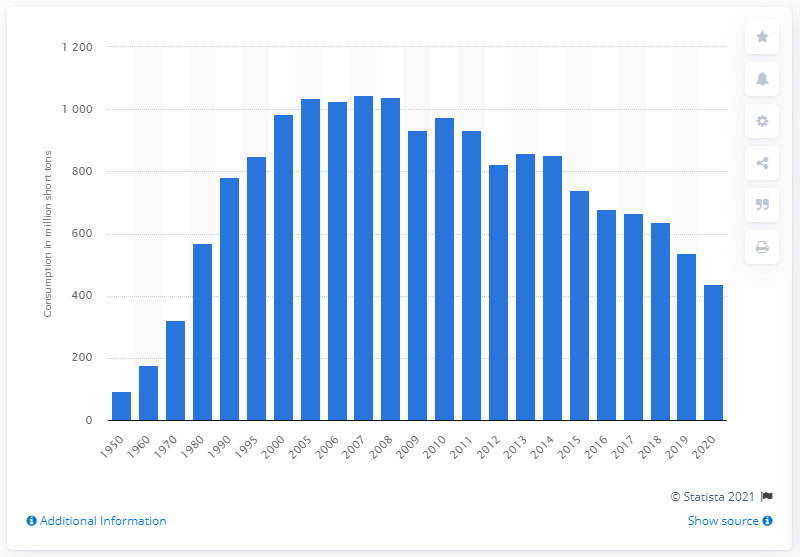Highlight a few significant elements in this photo. From 2005 to 2008, approximately 436.52 million short tons of coal were used annually. In 2020, the United States used 436.52 short tons of coal. 